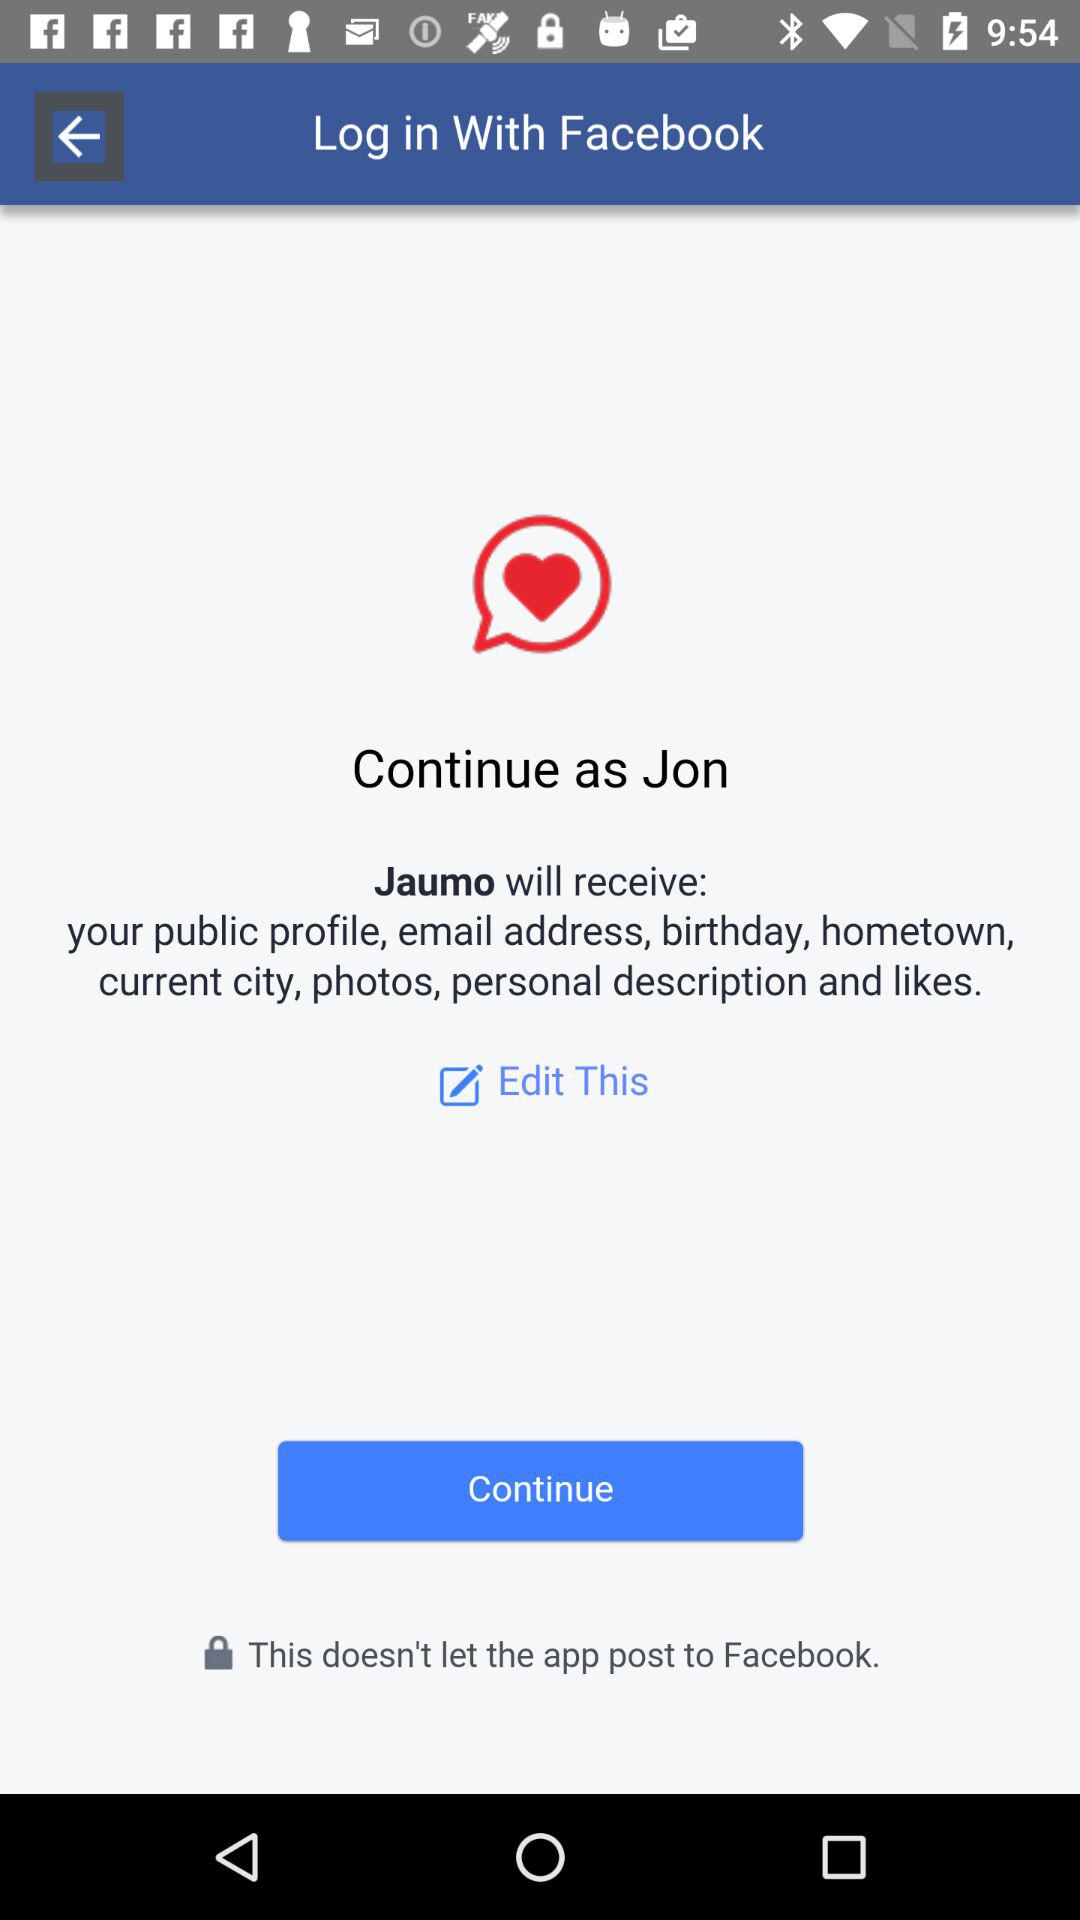What application is asking for permission? The application asking for permission is "Jaumo". 